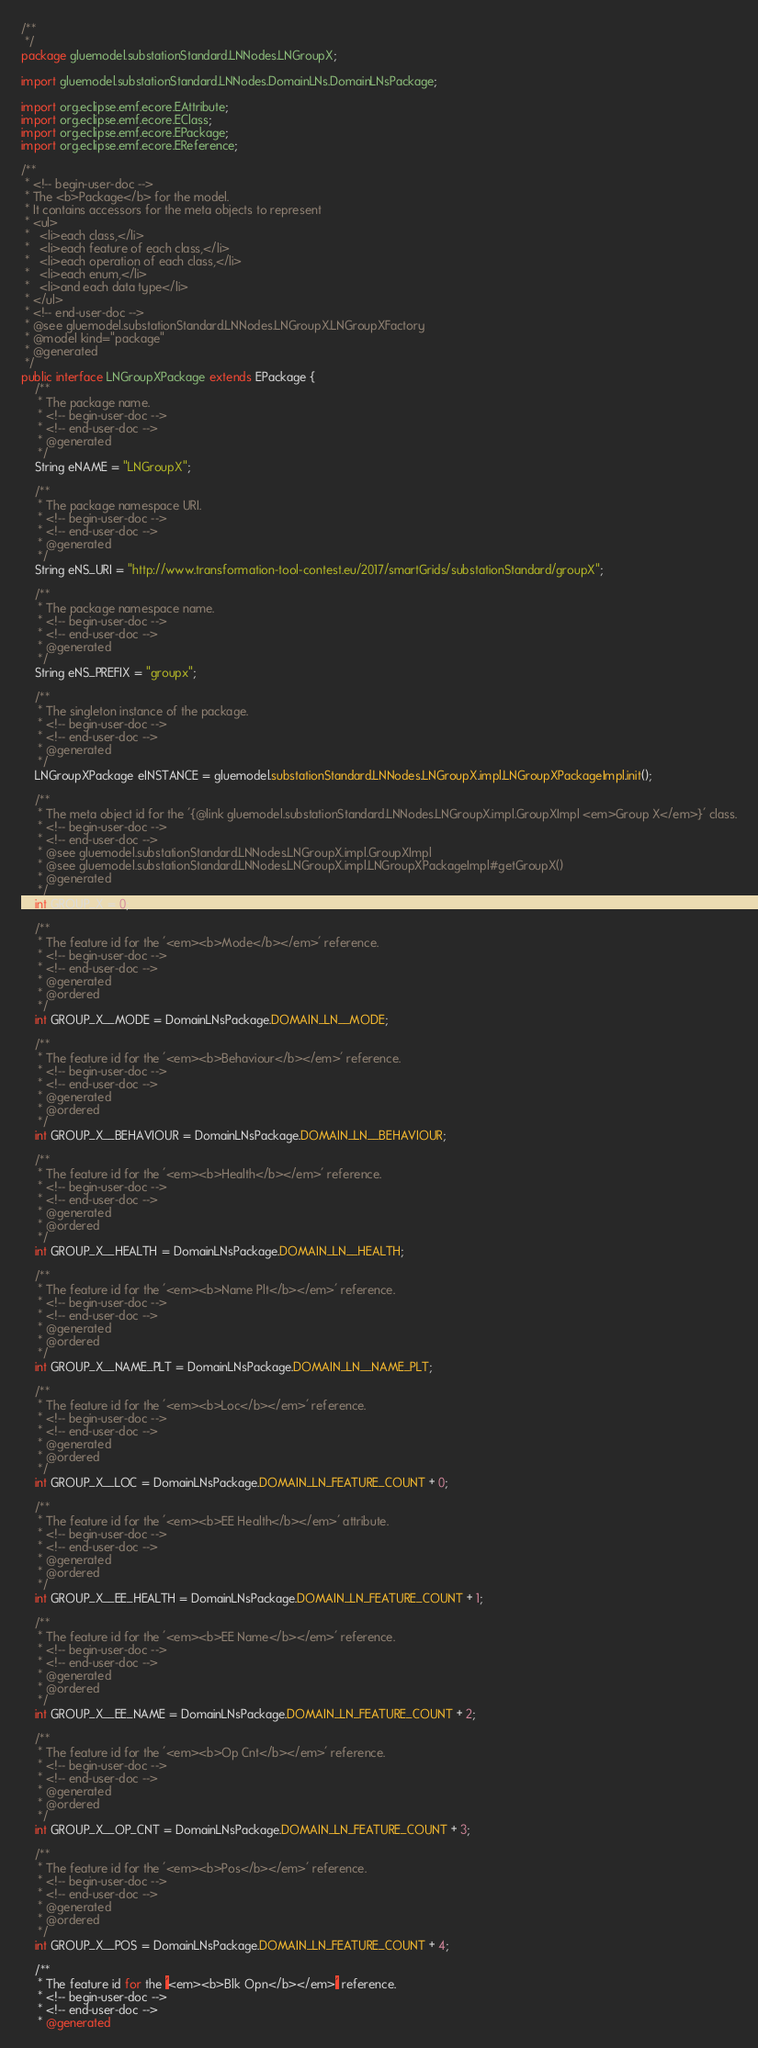<code> <loc_0><loc_0><loc_500><loc_500><_Java_>/**
 */
package gluemodel.substationStandard.LNNodes.LNGroupX;

import gluemodel.substationStandard.LNNodes.DomainLNs.DomainLNsPackage;

import org.eclipse.emf.ecore.EAttribute;
import org.eclipse.emf.ecore.EClass;
import org.eclipse.emf.ecore.EPackage;
import org.eclipse.emf.ecore.EReference;

/**
 * <!-- begin-user-doc -->
 * The <b>Package</b> for the model.
 * It contains accessors for the meta objects to represent
 * <ul>
 *   <li>each class,</li>
 *   <li>each feature of each class,</li>
 *   <li>each operation of each class,</li>
 *   <li>each enum,</li>
 *   <li>and each data type</li>
 * </ul>
 * <!-- end-user-doc -->
 * @see gluemodel.substationStandard.LNNodes.LNGroupX.LNGroupXFactory
 * @model kind="package"
 * @generated
 */
public interface LNGroupXPackage extends EPackage {
	/**
	 * The package name.
	 * <!-- begin-user-doc -->
	 * <!-- end-user-doc -->
	 * @generated
	 */
	String eNAME = "LNGroupX";

	/**
	 * The package namespace URI.
	 * <!-- begin-user-doc -->
	 * <!-- end-user-doc -->
	 * @generated
	 */
	String eNS_URI = "http://www.transformation-tool-contest.eu/2017/smartGrids/substationStandard/groupX";

	/**
	 * The package namespace name.
	 * <!-- begin-user-doc -->
	 * <!-- end-user-doc -->
	 * @generated
	 */
	String eNS_PREFIX = "groupx";

	/**
	 * The singleton instance of the package.
	 * <!-- begin-user-doc -->
	 * <!-- end-user-doc -->
	 * @generated
	 */
	LNGroupXPackage eINSTANCE = gluemodel.substationStandard.LNNodes.LNGroupX.impl.LNGroupXPackageImpl.init();

	/**
	 * The meta object id for the '{@link gluemodel.substationStandard.LNNodes.LNGroupX.impl.GroupXImpl <em>Group X</em>}' class.
	 * <!-- begin-user-doc -->
	 * <!-- end-user-doc -->
	 * @see gluemodel.substationStandard.LNNodes.LNGroupX.impl.GroupXImpl
	 * @see gluemodel.substationStandard.LNNodes.LNGroupX.impl.LNGroupXPackageImpl#getGroupX()
	 * @generated
	 */
	int GROUP_X = 0;

	/**
	 * The feature id for the '<em><b>Mode</b></em>' reference.
	 * <!-- begin-user-doc -->
	 * <!-- end-user-doc -->
	 * @generated
	 * @ordered
	 */
	int GROUP_X__MODE = DomainLNsPackage.DOMAIN_LN__MODE;

	/**
	 * The feature id for the '<em><b>Behaviour</b></em>' reference.
	 * <!-- begin-user-doc -->
	 * <!-- end-user-doc -->
	 * @generated
	 * @ordered
	 */
	int GROUP_X__BEHAVIOUR = DomainLNsPackage.DOMAIN_LN__BEHAVIOUR;

	/**
	 * The feature id for the '<em><b>Health</b></em>' reference.
	 * <!-- begin-user-doc -->
	 * <!-- end-user-doc -->
	 * @generated
	 * @ordered
	 */
	int GROUP_X__HEALTH = DomainLNsPackage.DOMAIN_LN__HEALTH;

	/**
	 * The feature id for the '<em><b>Name Plt</b></em>' reference.
	 * <!-- begin-user-doc -->
	 * <!-- end-user-doc -->
	 * @generated
	 * @ordered
	 */
	int GROUP_X__NAME_PLT = DomainLNsPackage.DOMAIN_LN__NAME_PLT;

	/**
	 * The feature id for the '<em><b>Loc</b></em>' reference.
	 * <!-- begin-user-doc -->
	 * <!-- end-user-doc -->
	 * @generated
	 * @ordered
	 */
	int GROUP_X__LOC = DomainLNsPackage.DOMAIN_LN_FEATURE_COUNT + 0;

	/**
	 * The feature id for the '<em><b>EE Health</b></em>' attribute.
	 * <!-- begin-user-doc -->
	 * <!-- end-user-doc -->
	 * @generated
	 * @ordered
	 */
	int GROUP_X__EE_HEALTH = DomainLNsPackage.DOMAIN_LN_FEATURE_COUNT + 1;

	/**
	 * The feature id for the '<em><b>EE Name</b></em>' reference.
	 * <!-- begin-user-doc -->
	 * <!-- end-user-doc -->
	 * @generated
	 * @ordered
	 */
	int GROUP_X__EE_NAME = DomainLNsPackage.DOMAIN_LN_FEATURE_COUNT + 2;

	/**
	 * The feature id for the '<em><b>Op Cnt</b></em>' reference.
	 * <!-- begin-user-doc -->
	 * <!-- end-user-doc -->
	 * @generated
	 * @ordered
	 */
	int GROUP_X__OP_CNT = DomainLNsPackage.DOMAIN_LN_FEATURE_COUNT + 3;

	/**
	 * The feature id for the '<em><b>Pos</b></em>' reference.
	 * <!-- begin-user-doc -->
	 * <!-- end-user-doc -->
	 * @generated
	 * @ordered
	 */
	int GROUP_X__POS = DomainLNsPackage.DOMAIN_LN_FEATURE_COUNT + 4;

	/**
	 * The feature id for the '<em><b>Blk Opn</b></em>' reference.
	 * <!-- begin-user-doc -->
	 * <!-- end-user-doc -->
	 * @generated</code> 